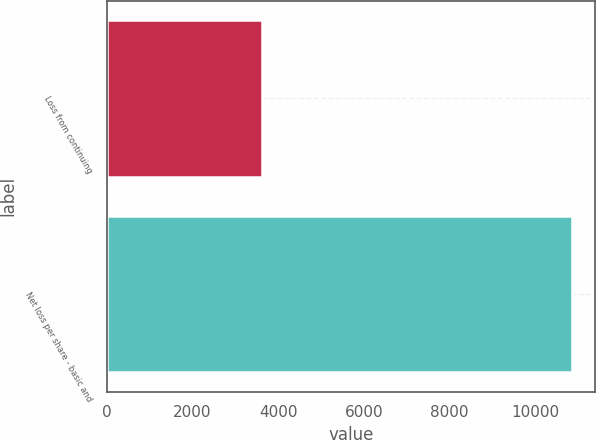Convert chart to OTSL. <chart><loc_0><loc_0><loc_500><loc_500><bar_chart><fcel>Loss from continuing<fcel>Net loss per share - basic and<nl><fcel>3617.85<fcel>10852.8<nl></chart> 